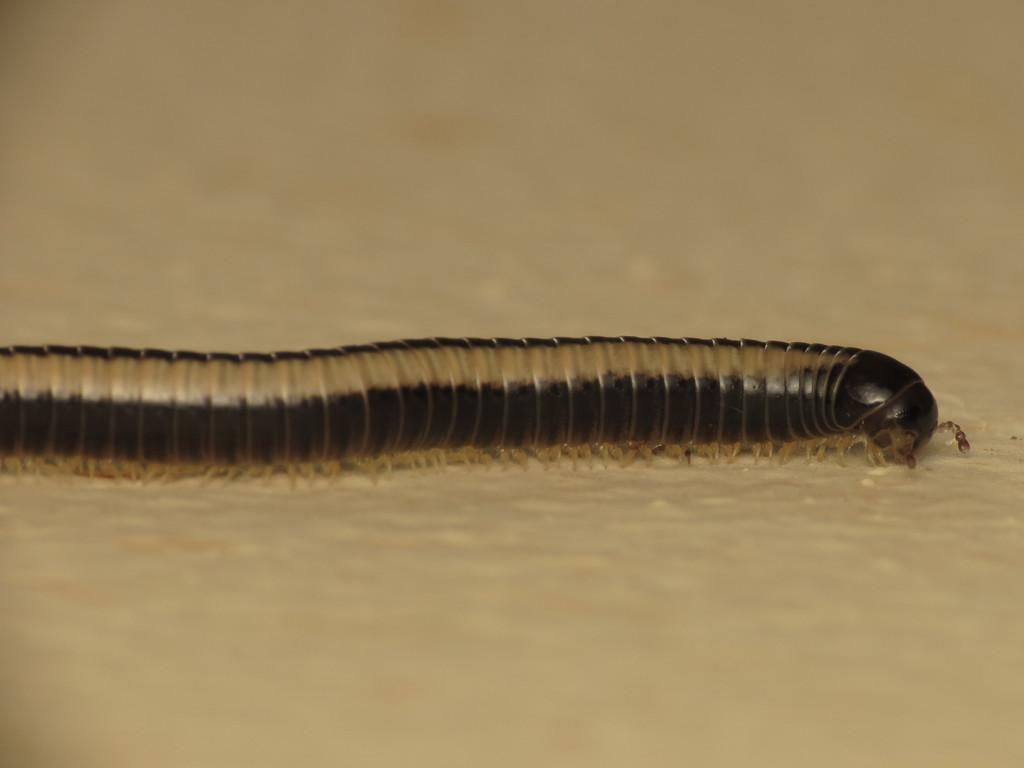What type of creature can be seen in the image? There is an insect in the image. Where is the insect located in the image? The insect is present on the ground. What type of carriage is being pulled by the insect in the image? There is no carriage present in the image; it only features an insect on the ground. 